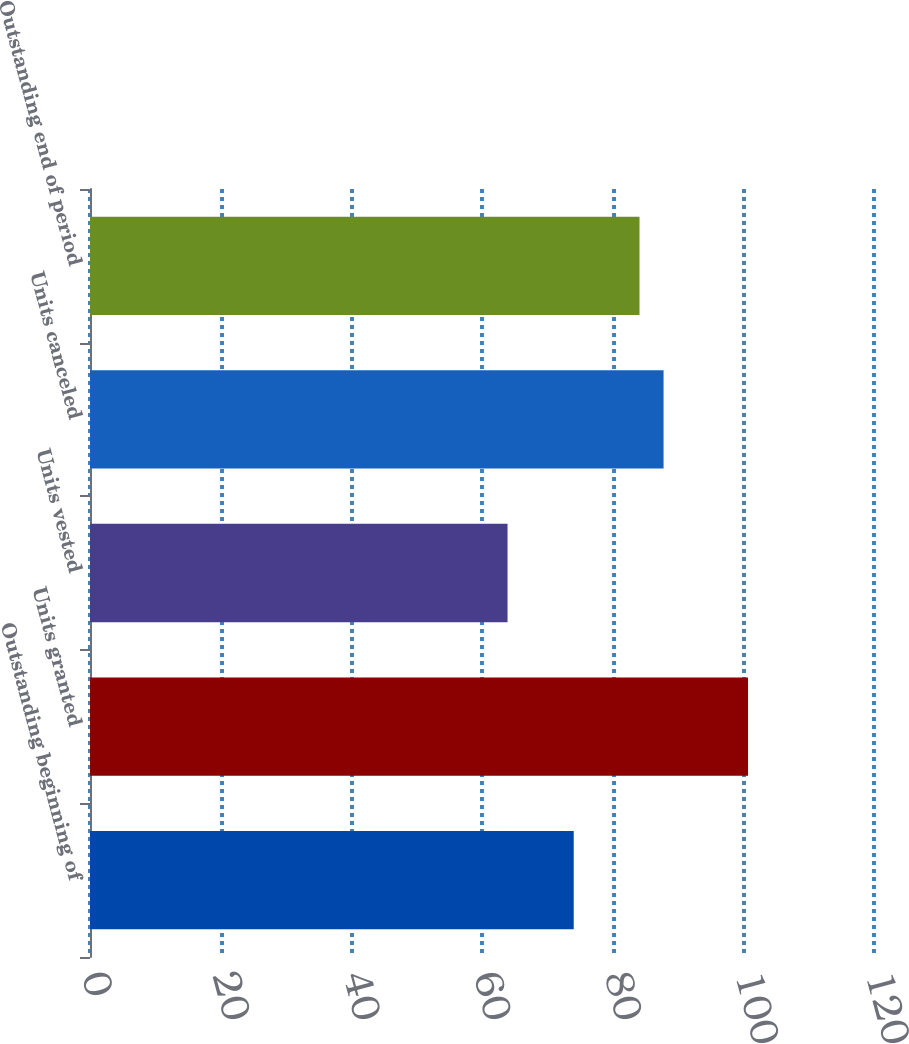<chart> <loc_0><loc_0><loc_500><loc_500><bar_chart><fcel>Outstanding beginning of<fcel>Units granted<fcel>Units vested<fcel>Units canceled<fcel>Outstanding end of period<nl><fcel>74.04<fcel>100.72<fcel>63.91<fcel>87.79<fcel>84.11<nl></chart> 